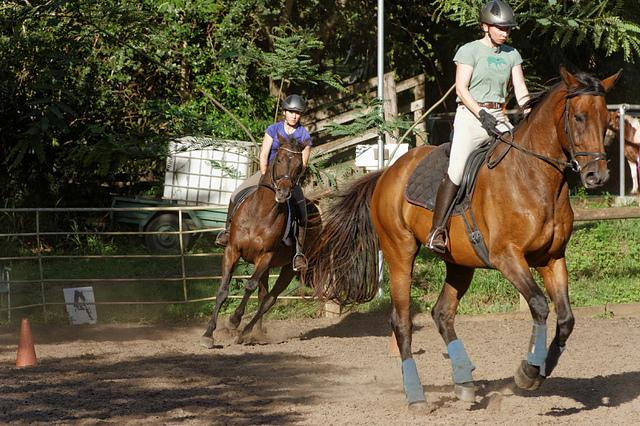Why do the people wear head gear? protection 